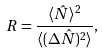<formula> <loc_0><loc_0><loc_500><loc_500>R = \frac { \langle { \hat { N } } \rangle ^ { 2 } } { \langle ( \Delta { \hat { N } } ) ^ { 2 } \rangle } ,</formula> 